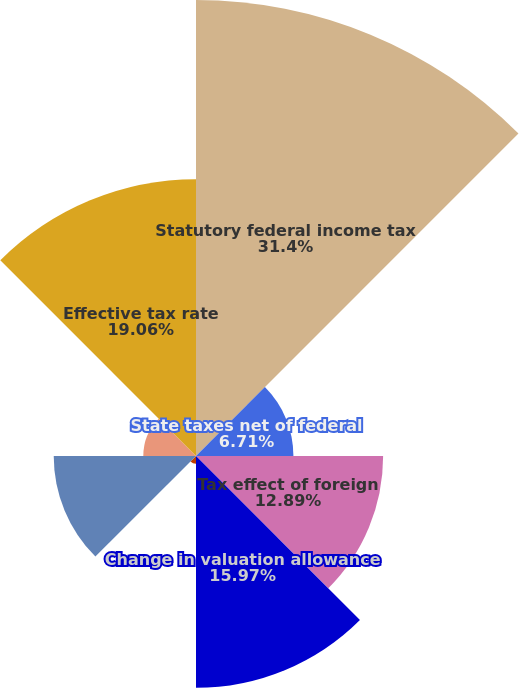Convert chart. <chart><loc_0><loc_0><loc_500><loc_500><pie_chart><fcel>Statutory federal income tax<fcel>State taxes net of federal<fcel>Tax effect of foreign<fcel>Change in valuation allowance<fcel>Change in uncertain tax<fcel>Permanent differences net<fcel>Other net<fcel>Effective tax rate<nl><fcel>31.41%<fcel>6.71%<fcel>12.89%<fcel>15.97%<fcel>0.54%<fcel>9.8%<fcel>3.63%<fcel>19.06%<nl></chart> 